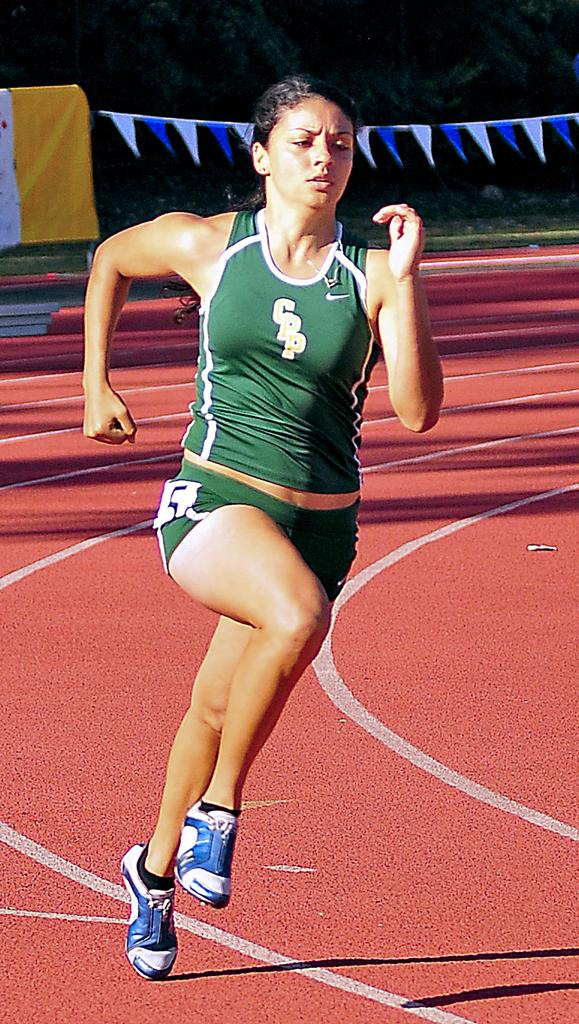<image>
Render a clear and concise summary of the photo. A woman in a shirt that says CPP runs on an outdoor track. 